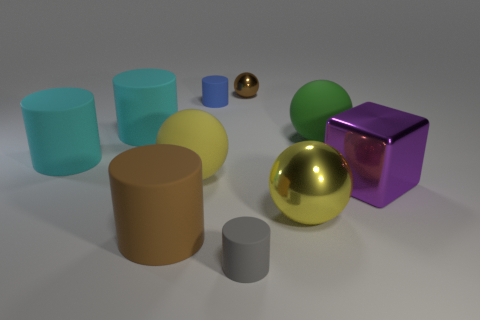Subtract all large matte cylinders. How many cylinders are left? 2 Subtract all green blocks. How many cyan cylinders are left? 2 Subtract all gray cylinders. How many cylinders are left? 4 Subtract 3 spheres. How many spheres are left? 1 Subtract all spheres. How many objects are left? 6 Add 3 large things. How many large things are left? 10 Add 4 large cyan rubber cylinders. How many large cyan rubber cylinders exist? 6 Subtract 1 brown spheres. How many objects are left? 9 Subtract all purple cylinders. Subtract all green balls. How many cylinders are left? 5 Subtract all brown spheres. Subtract all cyan matte objects. How many objects are left? 7 